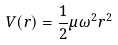<formula> <loc_0><loc_0><loc_500><loc_500>V ( r ) = \frac { 1 } { 2 } \mu \omega ^ { 2 } r ^ { 2 }</formula> 